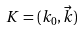Convert formula to latex. <formula><loc_0><loc_0><loc_500><loc_500>K = ( k _ { 0 } , { \vec { k } } )</formula> 